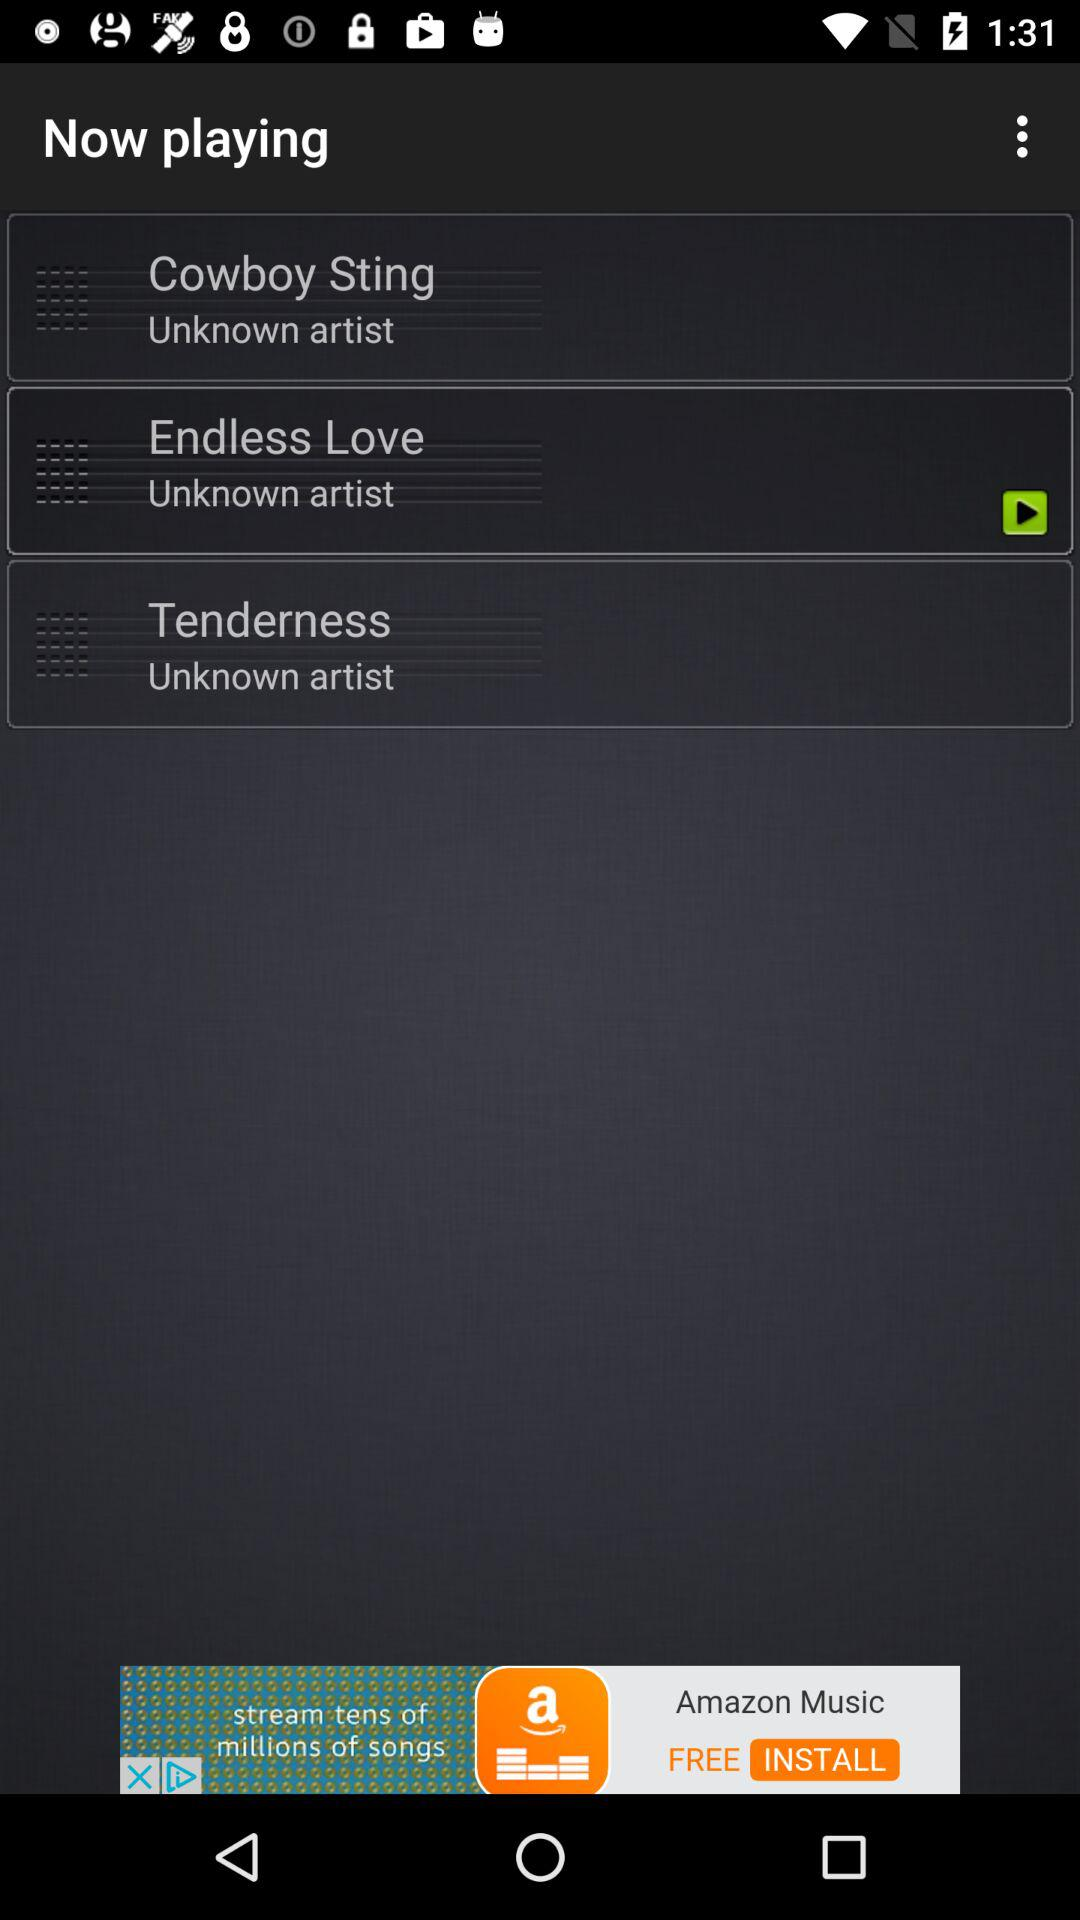How many songs have the artist 'Unknown artist'?
Answer the question using a single word or phrase. 3 